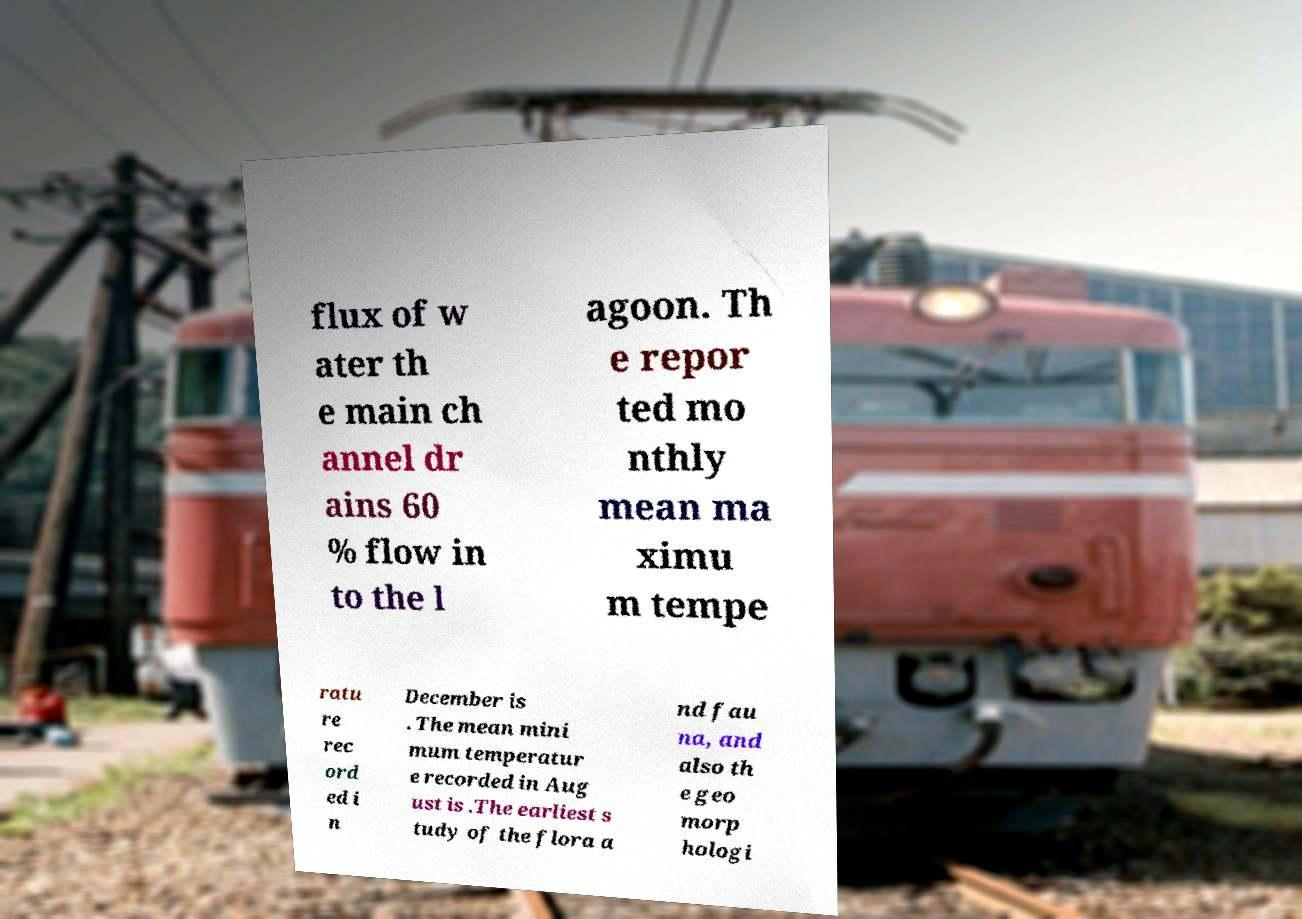Can you read and provide the text displayed in the image?This photo seems to have some interesting text. Can you extract and type it out for me? flux of w ater th e main ch annel dr ains 60 % flow in to the l agoon. Th e repor ted mo nthly mean ma ximu m tempe ratu re rec ord ed i n December is . The mean mini mum temperatur e recorded in Aug ust is .The earliest s tudy of the flora a nd fau na, and also th e geo morp hologi 